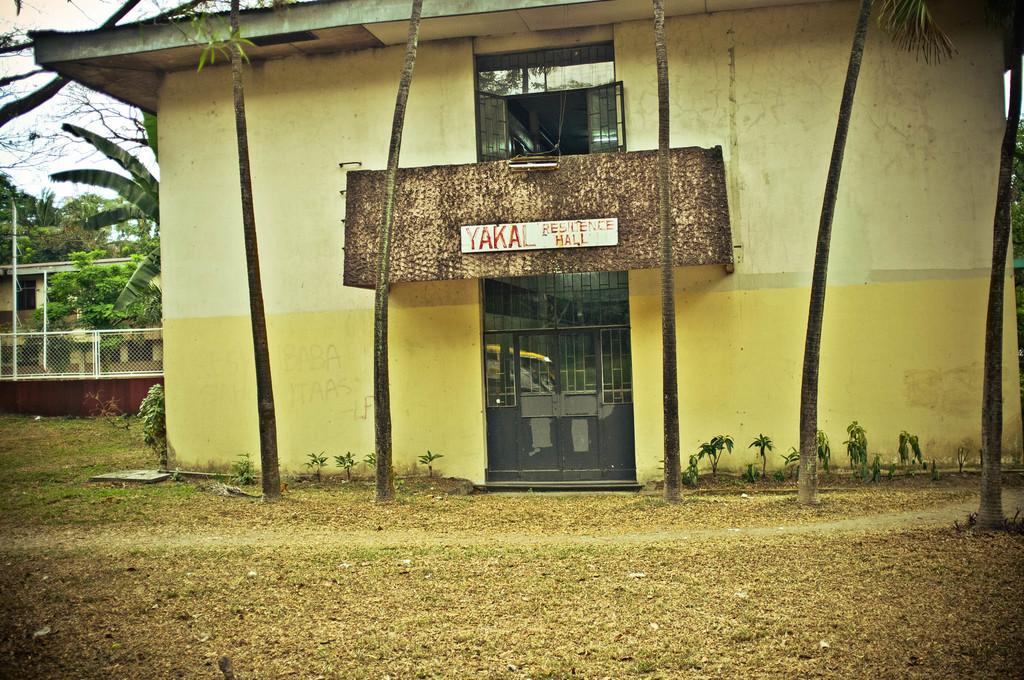What type of structure is visible in the image? There is a building in the image. What feature of the building is mentioned in the facts? The building has a door. What natural elements can be seen in the image? There are trees in the image. What is located at the right side of the image? There is a fence at the right side of the image. How would you describe the weather based on the image? The sky is clear in the image, suggesting good weather. How many horses are visible in the image? There are no horses present in the image. What type of currency can be seen in the image? There is no currency visible in the image. 